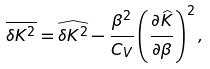Convert formula to latex. <formula><loc_0><loc_0><loc_500><loc_500>\overline { \delta K ^ { 2 } } = \widehat { \delta K ^ { 2 } } - \frac { \beta ^ { 2 } } { C _ { V } } \left ( \frac { \partial \widehat { K } } { \partial \beta } \right ) ^ { 2 } ,</formula> 